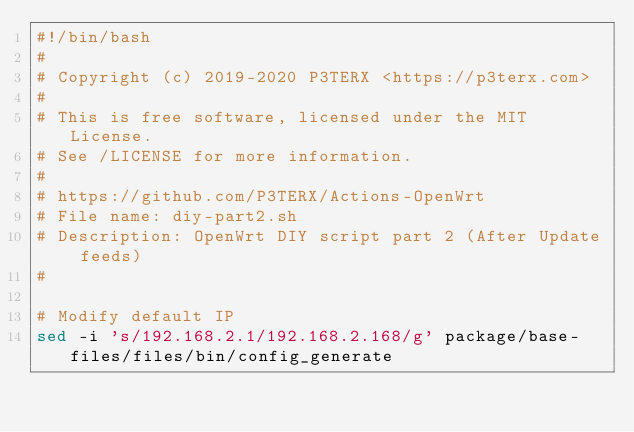<code> <loc_0><loc_0><loc_500><loc_500><_Bash_>#!/bin/bash
#
# Copyright (c) 2019-2020 P3TERX <https://p3terx.com>
#
# This is free software, licensed under the MIT License.
# See /LICENSE for more information.
#
# https://github.com/P3TERX/Actions-OpenWrt
# File name: diy-part2.sh
# Description: OpenWrt DIY script part 2 (After Update feeds)
#

# Modify default IP
sed -i 's/192.168.2.1/192.168.2.168/g' package/base-files/files/bin/config_generate
</code> 